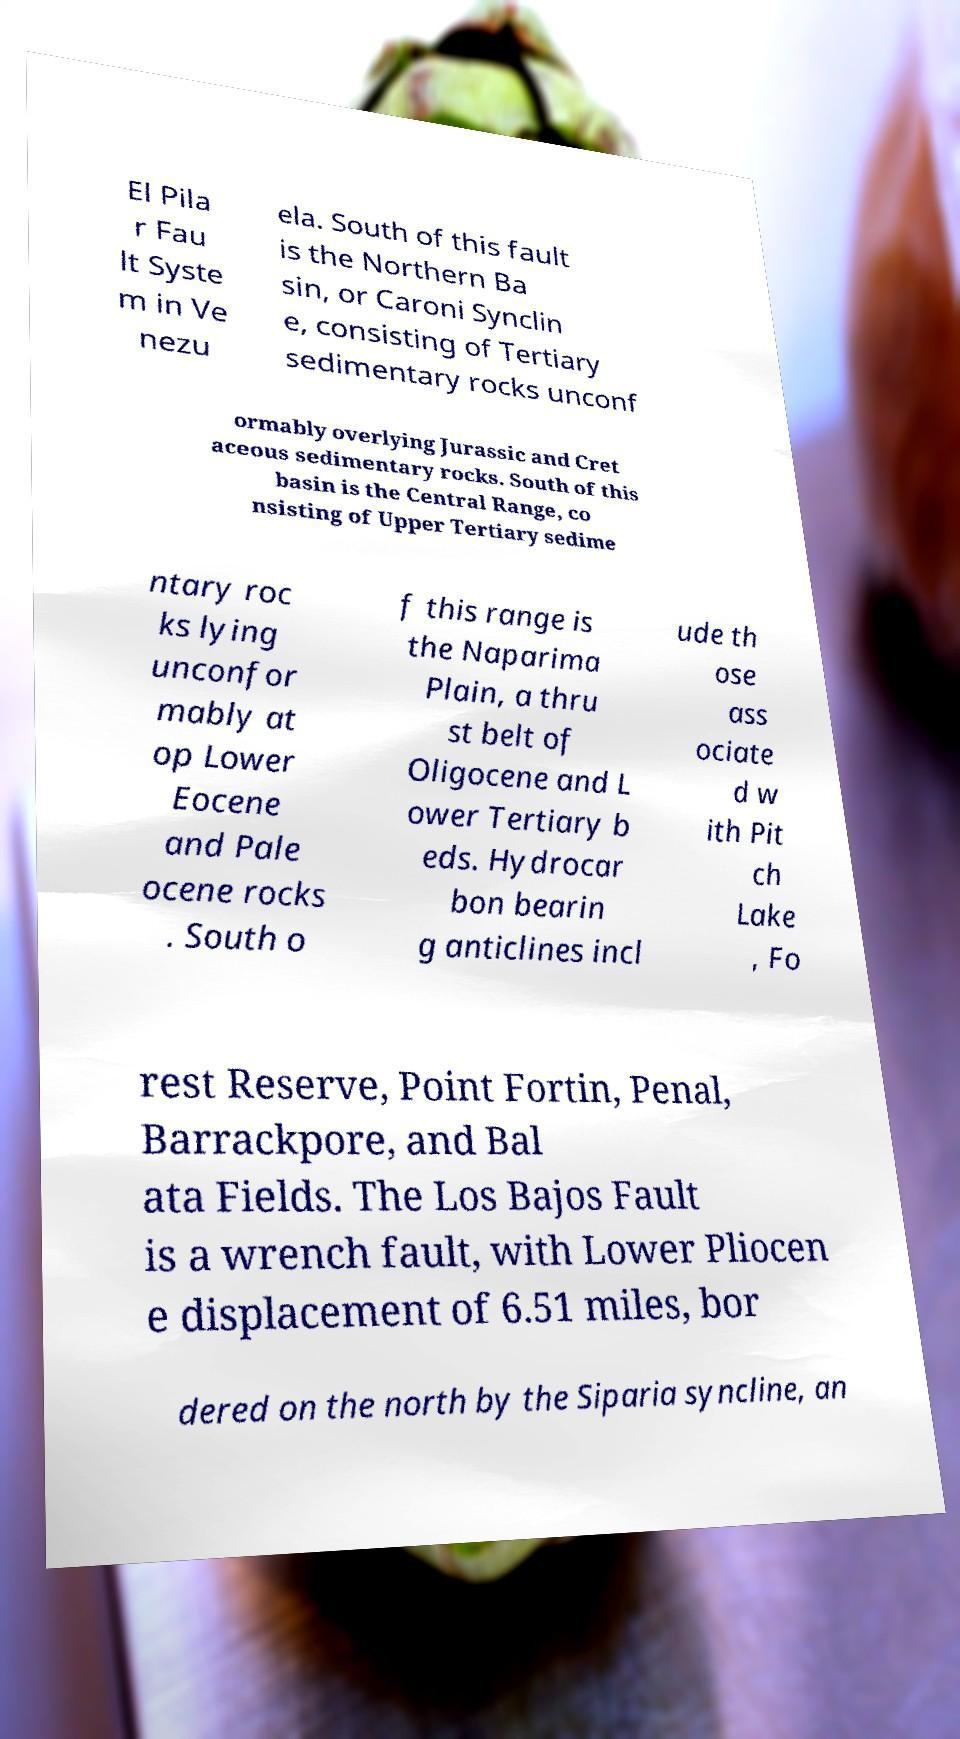Can you accurately transcribe the text from the provided image for me? El Pila r Fau lt Syste m in Ve nezu ela. South of this fault is the Northern Ba sin, or Caroni Synclin e, consisting of Tertiary sedimentary rocks unconf ormably overlying Jurassic and Cret aceous sedimentary rocks. South of this basin is the Central Range, co nsisting of Upper Tertiary sedime ntary roc ks lying unconfor mably at op Lower Eocene and Pale ocene rocks . South o f this range is the Naparima Plain, a thru st belt of Oligocene and L ower Tertiary b eds. Hydrocar bon bearin g anticlines incl ude th ose ass ociate d w ith Pit ch Lake , Fo rest Reserve, Point Fortin, Penal, Barrackpore, and Bal ata Fields. The Los Bajos Fault is a wrench fault, with Lower Pliocen e displacement of 6.51 miles, bor dered on the north by the Siparia syncline, an 